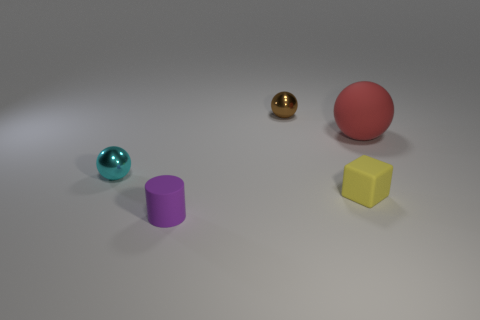Subtract all small cyan balls. How many balls are left? 2 Add 5 red matte objects. How many objects exist? 10 Subtract 1 cubes. How many cubes are left? 0 Subtract all cubes. How many objects are left? 4 Subtract all red blocks. How many brown cylinders are left? 0 Add 2 small matte things. How many small matte things are left? 4 Add 4 tiny metal spheres. How many tiny metal spheres exist? 6 Subtract 0 yellow spheres. How many objects are left? 5 Subtract all yellow cylinders. Subtract all green balls. How many cylinders are left? 1 Subtract all blue objects. Subtract all brown spheres. How many objects are left? 4 